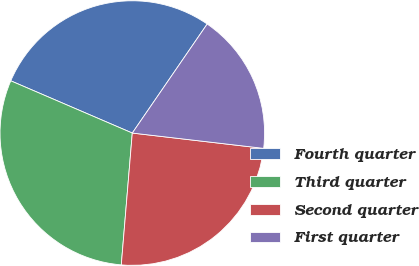Convert chart to OTSL. <chart><loc_0><loc_0><loc_500><loc_500><pie_chart><fcel>Fourth quarter<fcel>Third quarter<fcel>Second quarter<fcel>First quarter<nl><fcel>28.12%<fcel>30.14%<fcel>24.48%<fcel>17.27%<nl></chart> 